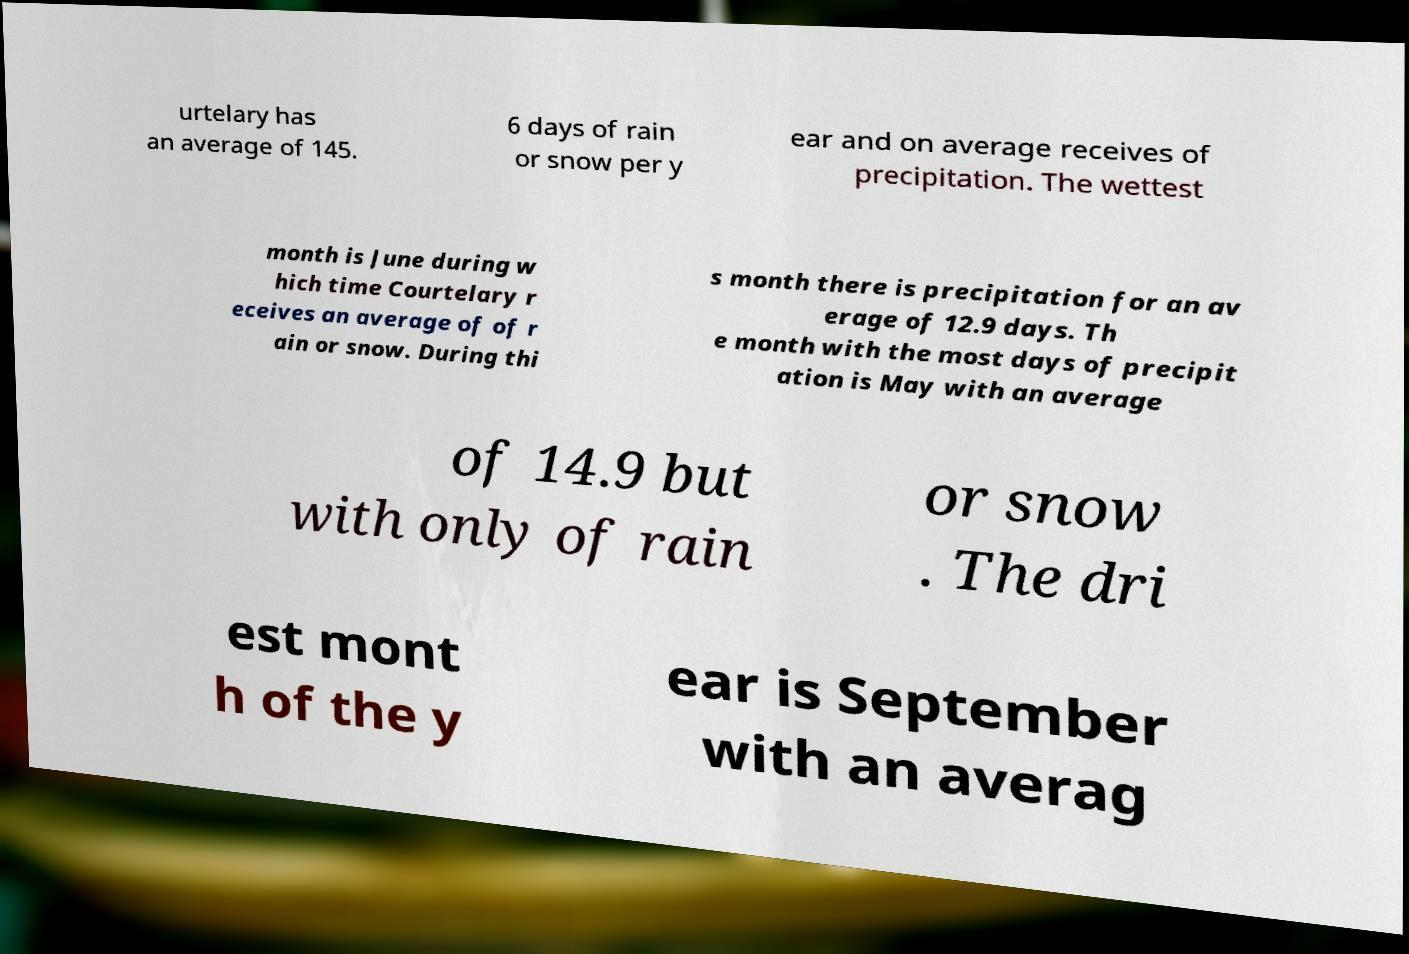There's text embedded in this image that I need extracted. Can you transcribe it verbatim? urtelary has an average of 145. 6 days of rain or snow per y ear and on average receives of precipitation. The wettest month is June during w hich time Courtelary r eceives an average of of r ain or snow. During thi s month there is precipitation for an av erage of 12.9 days. Th e month with the most days of precipit ation is May with an average of 14.9 but with only of rain or snow . The dri est mont h of the y ear is September with an averag 